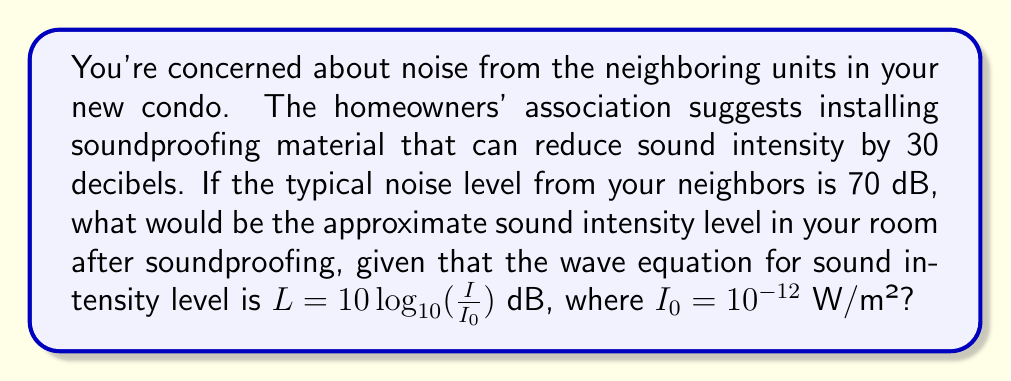Help me with this question. Let's approach this step-by-step:

1) We start with the wave equation for sound intensity level:

   $L = 10 \log_{10}(\frac{I}{I_0})$ dB

2) We're given that the initial noise level is 70 dB. Let's call the initial intensity $I_1$. So:

   $70 = 10 \log_{10}(\frac{I_1}{I_0})$

3) Solve for $I_1$:
   
   $7 = \log_{10}(\frac{I_1}{I_0})$
   $10^7 = \frac{I_1}{I_0}$
   $I_1 = 10^7 \cdot I_0 = 10^7 \cdot 10^{-12} = 10^{-5}$ W/m²

4) The soundproofing reduces the intensity by 30 dB. Let's call the new intensity $I_2$. This means:

   $30 = 10 \log_{10}(\frac{I_1}{I_2})$

5) Solve for $I_2$:

   $3 = \log_{10}(\frac{I_1}{I_2})$
   $10^3 = \frac{I_1}{I_2}$
   $I_2 = \frac{I_1}{10^3} = \frac{10^{-5}}{10^3} = 10^{-8}$ W/m²

6) Now, let's calculate the new sound intensity level $L_2$:

   $L_2 = 10 \log_{10}(\frac{I_2}{I_0}) = 10 \log_{10}(\frac{10^{-8}}{10^{-12}}) = 10 \log_{10}(10^4) = 40$ dB

Therefore, after soundproofing, the approximate sound intensity level in your room would be 40 dB.
Answer: 40 dB 